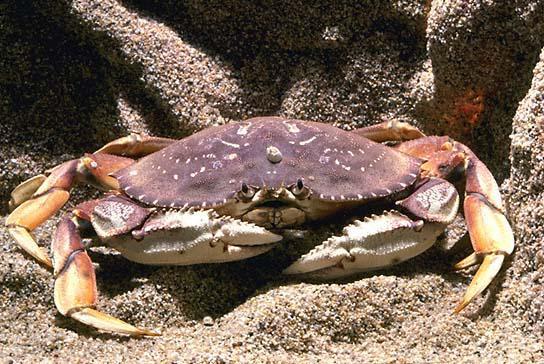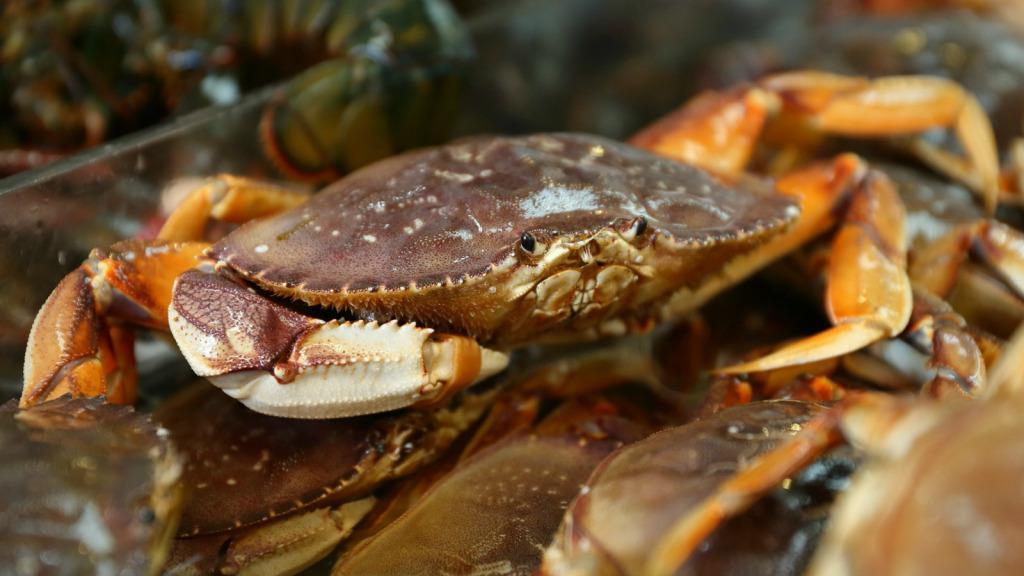The first image is the image on the left, the second image is the image on the right. Assess this claim about the two images: "There are exactly two live crabs.". Correct or not? Answer yes or no. Yes. The first image is the image on the left, the second image is the image on the right. For the images displayed, is the sentence "A single crab sits on a sediment surface in the image on the right." factually correct? Answer yes or no. No. 